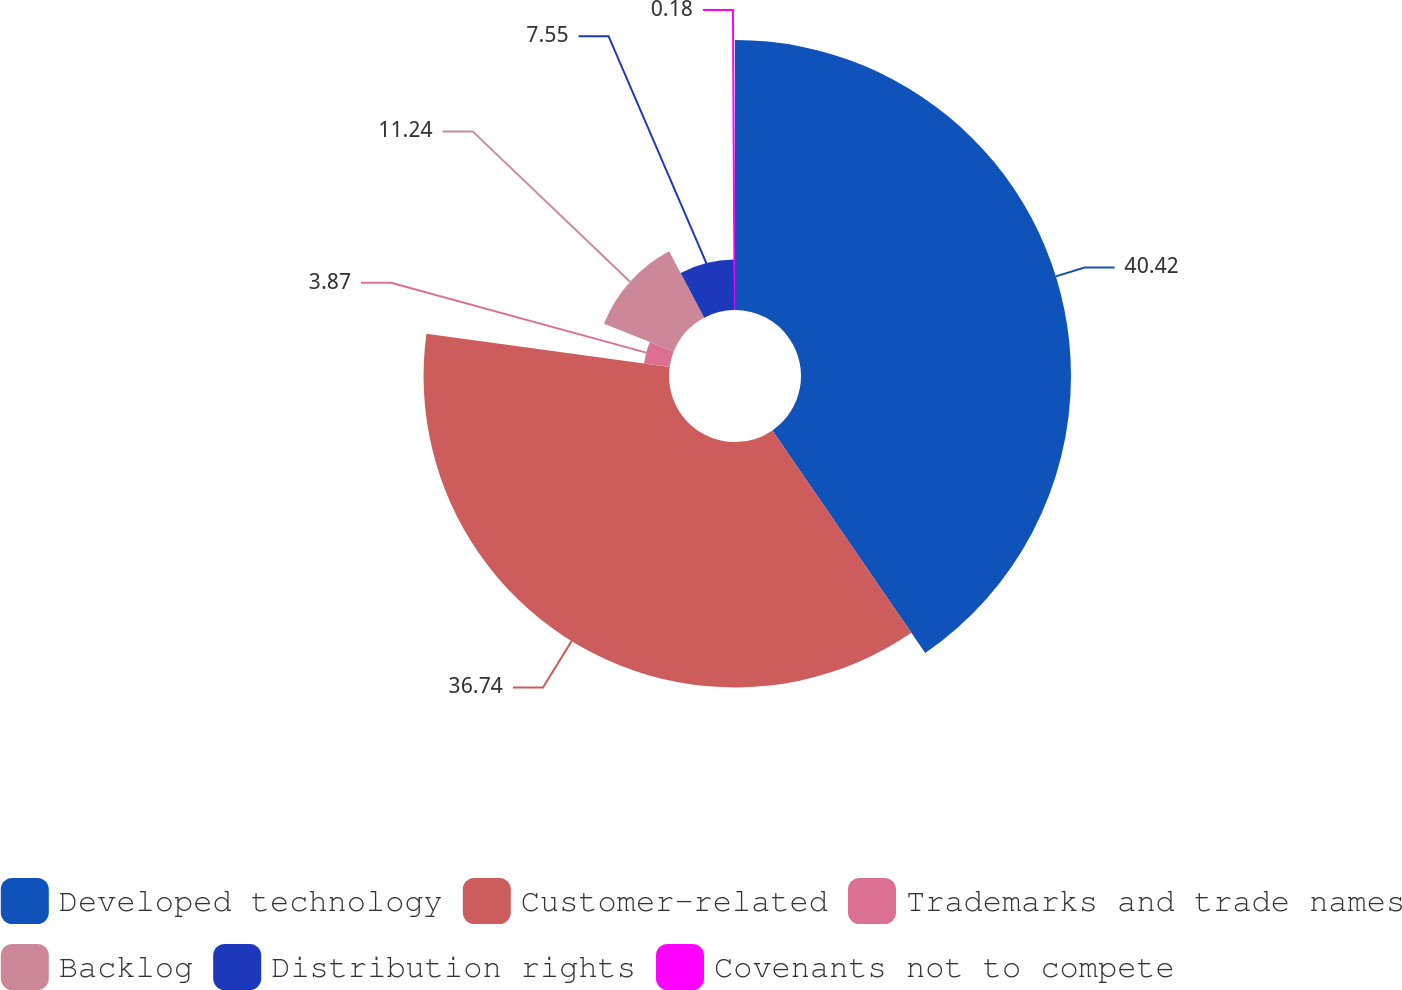<chart> <loc_0><loc_0><loc_500><loc_500><pie_chart><fcel>Developed technology<fcel>Customer-related<fcel>Trademarks and trade names<fcel>Backlog<fcel>Distribution rights<fcel>Covenants not to compete<nl><fcel>40.42%<fcel>36.74%<fcel>3.87%<fcel>11.24%<fcel>7.55%<fcel>0.18%<nl></chart> 